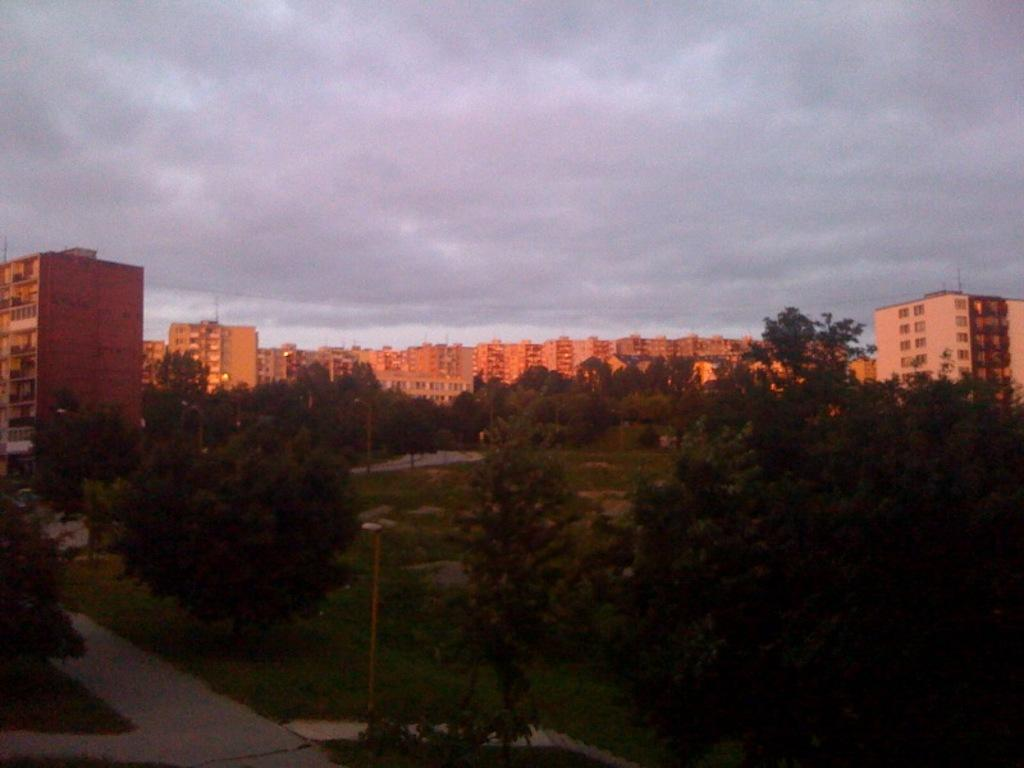What type of path is visible in the image? There is a walkway in the image. What structures can be seen supporting something in the image? There are poles in the image. What illuminates the walkway in the image? There are lights in the image. What type of vegetation is present in the image? There are trees, grass, and plants in the image. What type of man-made structures are visible in the image? There are buildings in the image. What part of the natural environment is visible in the image? The sky is visible in the image. What team is playing ice hockey on the walkway in the image? There is no team playing ice hockey or any other sport on the walkway in the image. What type of ice can be seen melting on the poles in the image? There is no ice present on the poles or anywhere else in the image. 